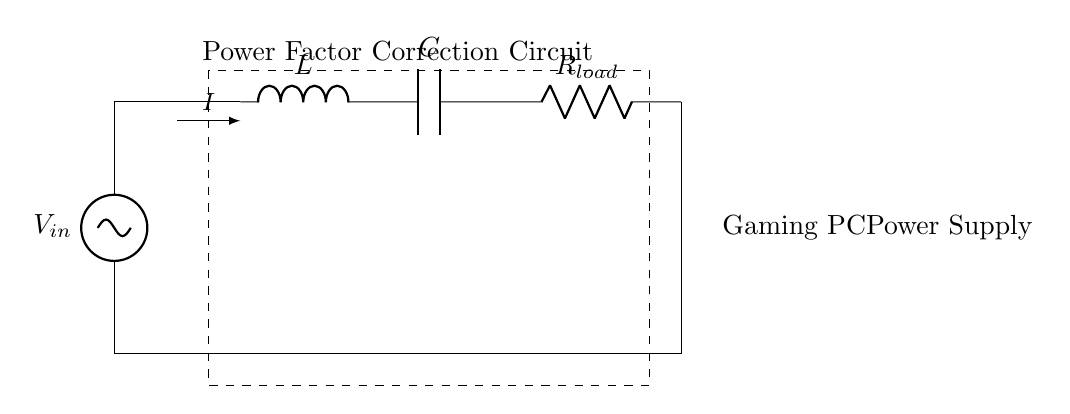What is the purpose of the inductor in this circuit? The inductor is primarily used to store energy in a magnetic field when current flows through it. In power factor correction circuits, it helps to improve the overall power factor by counteracting the capacitive effects.
Answer: Energy storage What is the component labeled as R_load? The component R_load is a resistor that represents the load in the circuit. It represents the actual consumption of power in the gaming PC's power supply.
Answer: Resistor What is the current direction in this circuit? The current direction is indicated by the arrow showing current I, which flows from the AC source through the circuit components. It moves through the inductor, capacitor, and resistor sequentially.
Answer: From AC source to load How many reactive components are in this circuit? There are two reactive components, which are the inductor and capacitor. These components store energy in either magnetic or electric fields and influence the phase of the current.
Answer: Two Why is this circuit designed for power factor correction? This circuit is designed for power factor correction to reduce the phase difference between voltage and current, ultimately improving efficiency and reducing losses in the power supply system of the gaming PC.
Answer: Improve efficiency What are the two stored energies in this RLC circuit? The two stored energies in this RLC circuit are magnetic energy stored in the inductor and electric energy stored in the capacitor. Together, they help maintain the circuit's stability and improve power factor.
Answer: Magnetic and electric energy What type of circuit is shown in the diagram? The circuit shown is a power factor correction circuit consisting of resistors, inductors, and capacitors (RLC). This type is used to manage the inductive and capacitive loads effectively.
Answer: RLC circuit 